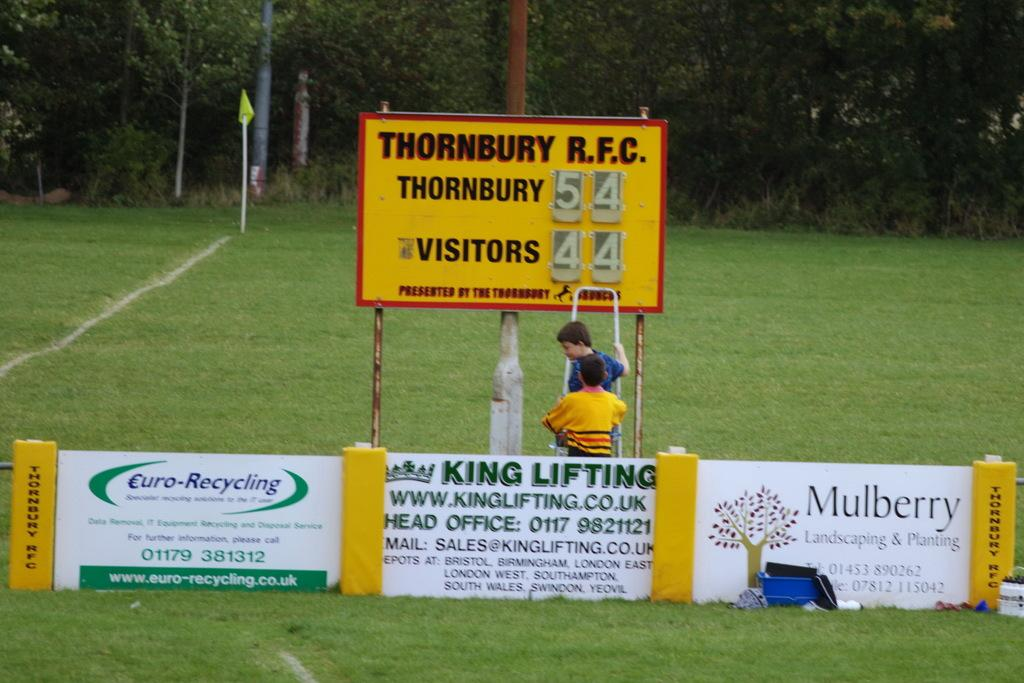<image>
Offer a succinct explanation of the picture presented. Advertising signs in Thornbury R.F.C listing the number of visitors and Thornbury residents. 